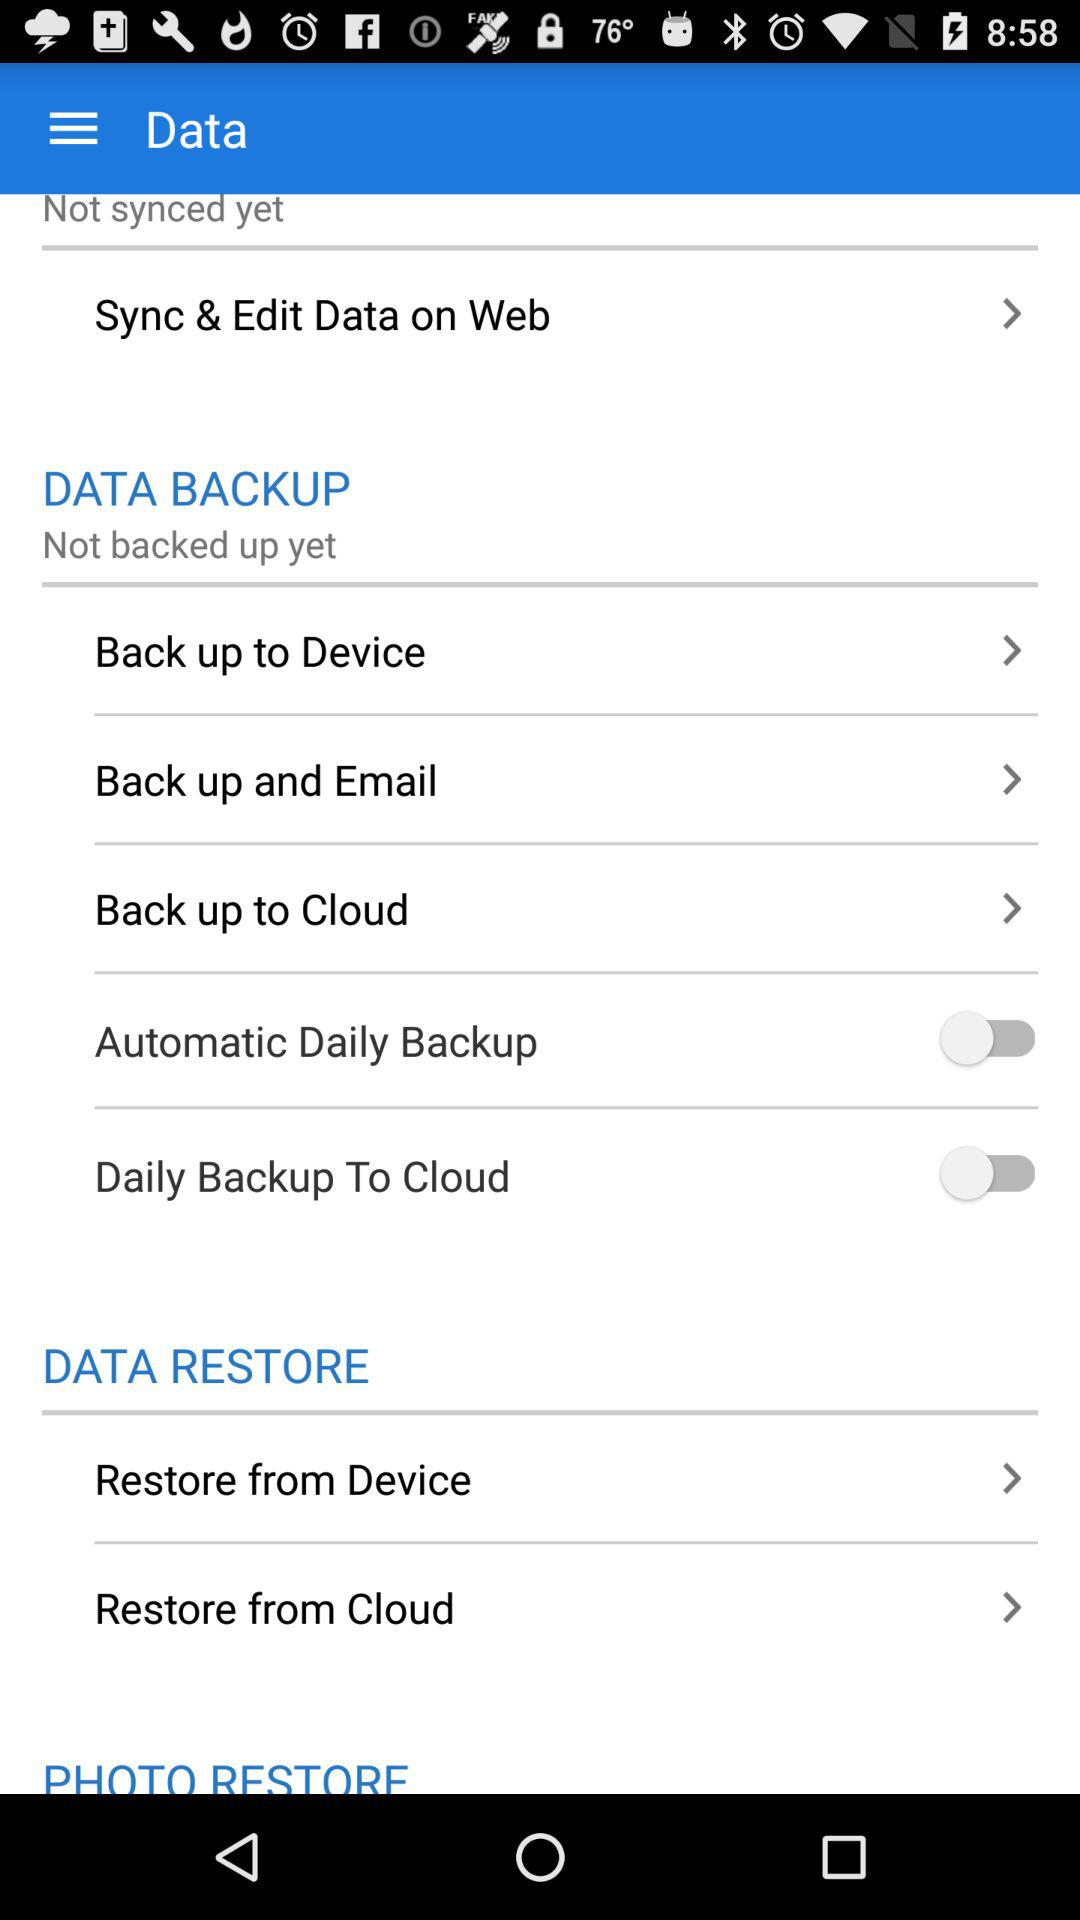What version is this?
When the provided information is insufficient, respond with <no answer>. <no answer> 